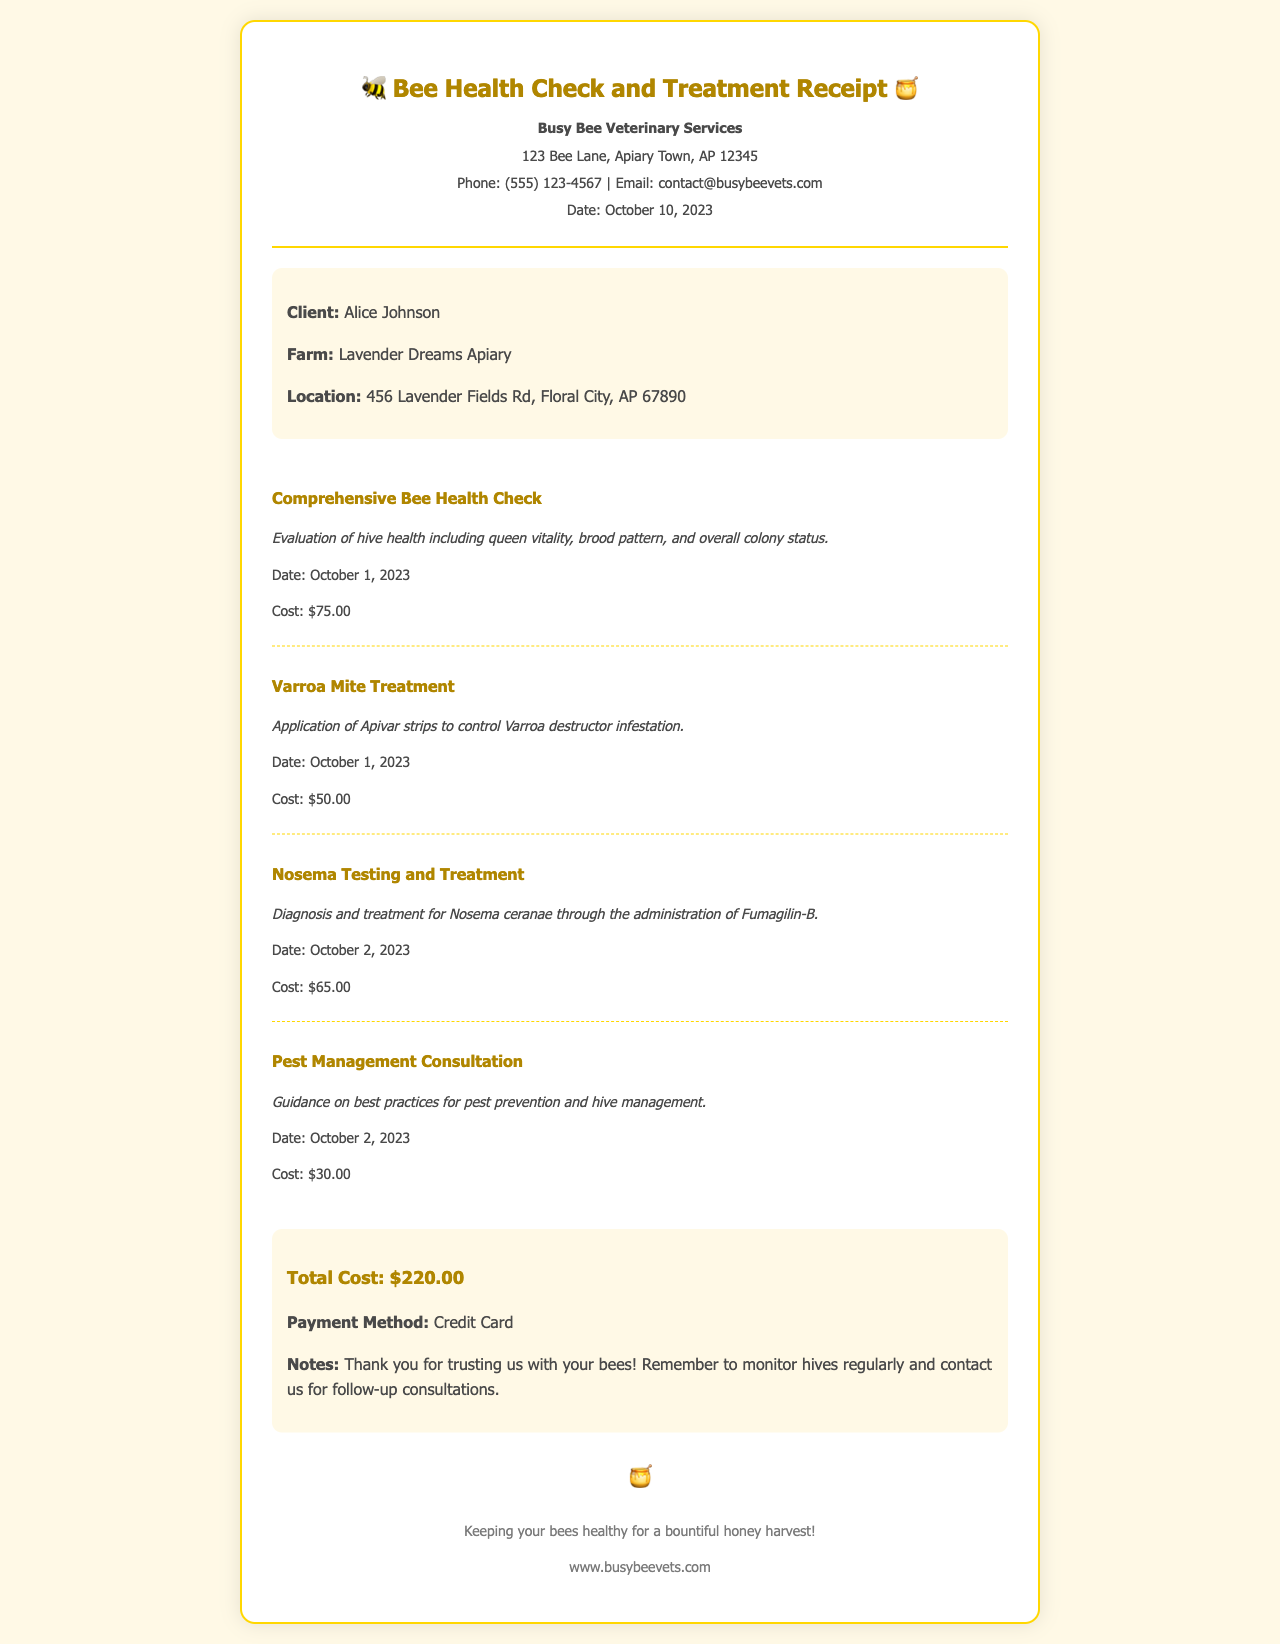What is the name of the veterinary service? The name of the veterinary service is indicated at the top of the document, which is Busy Bee Veterinary Services.
Answer: Busy Bee Veterinary Services What was the date of the receipt? The date of the receipt can be found in the header section, listed as October 10, 2023.
Answer: October 10, 2023 How much did the Varroa Mite Treatment cost? The cost is provided in the services section specifically for Varroa Mite Treatment, which is $50.00.
Answer: $50.00 Who is the client listed on the receipt? The client's name is listed in the client information section as Alice Johnson.
Answer: Alice Johnson What total amount did the services cost? The total cost is summarized at the end of the document, which is $220.00.
Answer: $220.00 On what date was the Nosema Testing and Treatment performed? The date for this service can be found in the services section, specifically listed as October 2, 2023.
Answer: October 2, 2023 Which pest management product was recommended? The recommended product is mentioned in the service description for the Nosema Testing and Treatment, which is Fumagilin-B.
Answer: Fumagilin-B What is included in the Comprehensive Bee Health Check? The service description outlines that it includes evaluation of hive health, queen vitality, brood pattern, and overall colony status.
Answer: Evaluation of hive health, queen vitality, brood pattern, and overall colony status What method of payment was used for the services? The method of payment is detailed at the end of the document as Credit Card.
Answer: Credit Card 